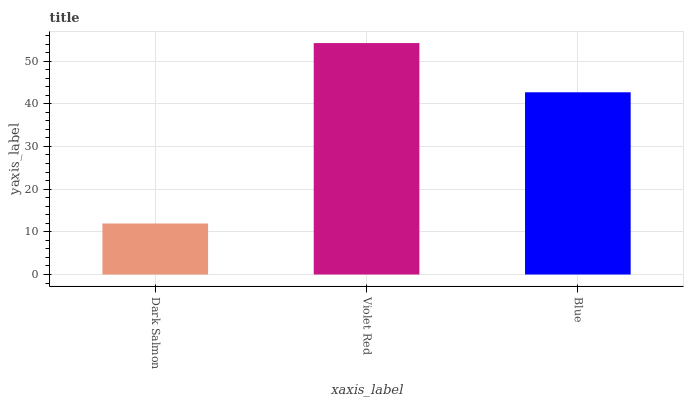Is Dark Salmon the minimum?
Answer yes or no. Yes. Is Violet Red the maximum?
Answer yes or no. Yes. Is Blue the minimum?
Answer yes or no. No. Is Blue the maximum?
Answer yes or no. No. Is Violet Red greater than Blue?
Answer yes or no. Yes. Is Blue less than Violet Red?
Answer yes or no. Yes. Is Blue greater than Violet Red?
Answer yes or no. No. Is Violet Red less than Blue?
Answer yes or no. No. Is Blue the high median?
Answer yes or no. Yes. Is Blue the low median?
Answer yes or no. Yes. Is Violet Red the high median?
Answer yes or no. No. Is Violet Red the low median?
Answer yes or no. No. 